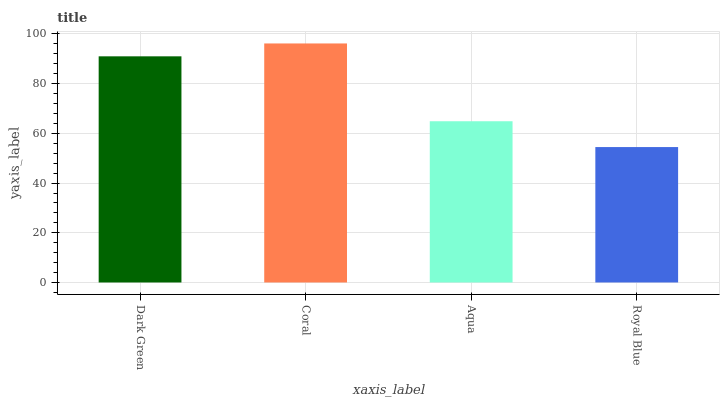Is Aqua the minimum?
Answer yes or no. No. Is Aqua the maximum?
Answer yes or no. No. Is Coral greater than Aqua?
Answer yes or no. Yes. Is Aqua less than Coral?
Answer yes or no. Yes. Is Aqua greater than Coral?
Answer yes or no. No. Is Coral less than Aqua?
Answer yes or no. No. Is Dark Green the high median?
Answer yes or no. Yes. Is Aqua the low median?
Answer yes or no. Yes. Is Aqua the high median?
Answer yes or no. No. Is Dark Green the low median?
Answer yes or no. No. 